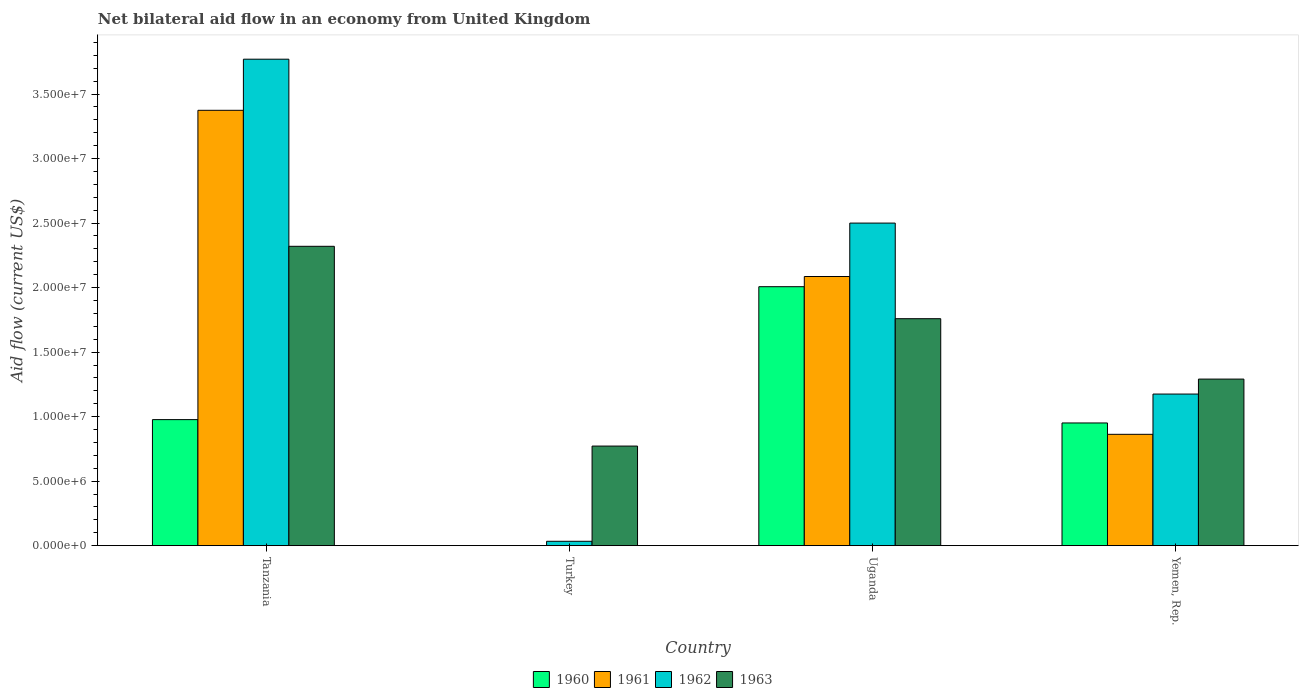How many different coloured bars are there?
Offer a terse response. 4. How many groups of bars are there?
Your answer should be very brief. 4. What is the label of the 3rd group of bars from the left?
Your answer should be compact. Uganda. Across all countries, what is the maximum net bilateral aid flow in 1963?
Offer a very short reply. 2.32e+07. Across all countries, what is the minimum net bilateral aid flow in 1961?
Give a very brief answer. 0. In which country was the net bilateral aid flow in 1961 maximum?
Make the answer very short. Tanzania. What is the total net bilateral aid flow in 1960 in the graph?
Your response must be concise. 3.94e+07. What is the difference between the net bilateral aid flow in 1960 in Tanzania and that in Yemen, Rep.?
Offer a terse response. 2.60e+05. What is the difference between the net bilateral aid flow in 1962 in Tanzania and the net bilateral aid flow in 1960 in Yemen, Rep.?
Your answer should be very brief. 2.82e+07. What is the average net bilateral aid flow in 1962 per country?
Your response must be concise. 1.87e+07. What is the difference between the net bilateral aid flow of/in 1961 and net bilateral aid flow of/in 1963 in Tanzania?
Provide a short and direct response. 1.05e+07. What is the ratio of the net bilateral aid flow in 1961 in Tanzania to that in Yemen, Rep.?
Your answer should be very brief. 3.91. Is the difference between the net bilateral aid flow in 1961 in Tanzania and Yemen, Rep. greater than the difference between the net bilateral aid flow in 1963 in Tanzania and Yemen, Rep.?
Your answer should be compact. Yes. What is the difference between the highest and the second highest net bilateral aid flow in 1962?
Your answer should be very brief. 1.27e+07. What is the difference between the highest and the lowest net bilateral aid flow in 1962?
Offer a very short reply. 3.74e+07. How many countries are there in the graph?
Offer a terse response. 4. What is the difference between two consecutive major ticks on the Y-axis?
Provide a succinct answer. 5.00e+06. Does the graph contain grids?
Your answer should be very brief. No. Where does the legend appear in the graph?
Offer a terse response. Bottom center. What is the title of the graph?
Provide a succinct answer. Net bilateral aid flow in an economy from United Kingdom. Does "2008" appear as one of the legend labels in the graph?
Your response must be concise. No. What is the Aid flow (current US$) in 1960 in Tanzania?
Your answer should be compact. 9.77e+06. What is the Aid flow (current US$) of 1961 in Tanzania?
Keep it short and to the point. 3.37e+07. What is the Aid flow (current US$) in 1962 in Tanzania?
Your answer should be compact. 3.77e+07. What is the Aid flow (current US$) of 1963 in Tanzania?
Keep it short and to the point. 2.32e+07. What is the Aid flow (current US$) in 1960 in Turkey?
Provide a succinct answer. 0. What is the Aid flow (current US$) of 1963 in Turkey?
Keep it short and to the point. 7.72e+06. What is the Aid flow (current US$) in 1960 in Uganda?
Offer a very short reply. 2.01e+07. What is the Aid flow (current US$) of 1961 in Uganda?
Offer a very short reply. 2.09e+07. What is the Aid flow (current US$) in 1962 in Uganda?
Offer a very short reply. 2.50e+07. What is the Aid flow (current US$) of 1963 in Uganda?
Offer a very short reply. 1.76e+07. What is the Aid flow (current US$) of 1960 in Yemen, Rep.?
Your response must be concise. 9.51e+06. What is the Aid flow (current US$) of 1961 in Yemen, Rep.?
Your response must be concise. 8.63e+06. What is the Aid flow (current US$) in 1962 in Yemen, Rep.?
Offer a terse response. 1.18e+07. What is the Aid flow (current US$) in 1963 in Yemen, Rep.?
Offer a very short reply. 1.29e+07. Across all countries, what is the maximum Aid flow (current US$) of 1960?
Provide a succinct answer. 2.01e+07. Across all countries, what is the maximum Aid flow (current US$) of 1961?
Your response must be concise. 3.37e+07. Across all countries, what is the maximum Aid flow (current US$) in 1962?
Offer a terse response. 3.77e+07. Across all countries, what is the maximum Aid flow (current US$) in 1963?
Keep it short and to the point. 2.32e+07. Across all countries, what is the minimum Aid flow (current US$) in 1963?
Ensure brevity in your answer.  7.72e+06. What is the total Aid flow (current US$) in 1960 in the graph?
Keep it short and to the point. 3.94e+07. What is the total Aid flow (current US$) in 1961 in the graph?
Provide a succinct answer. 6.32e+07. What is the total Aid flow (current US$) in 1962 in the graph?
Make the answer very short. 7.48e+07. What is the total Aid flow (current US$) of 1963 in the graph?
Offer a very short reply. 6.14e+07. What is the difference between the Aid flow (current US$) in 1962 in Tanzania and that in Turkey?
Offer a terse response. 3.74e+07. What is the difference between the Aid flow (current US$) in 1963 in Tanzania and that in Turkey?
Ensure brevity in your answer.  1.55e+07. What is the difference between the Aid flow (current US$) of 1960 in Tanzania and that in Uganda?
Make the answer very short. -1.03e+07. What is the difference between the Aid flow (current US$) of 1961 in Tanzania and that in Uganda?
Your answer should be very brief. 1.29e+07. What is the difference between the Aid flow (current US$) in 1962 in Tanzania and that in Uganda?
Provide a succinct answer. 1.27e+07. What is the difference between the Aid flow (current US$) of 1963 in Tanzania and that in Uganda?
Provide a short and direct response. 5.61e+06. What is the difference between the Aid flow (current US$) in 1960 in Tanzania and that in Yemen, Rep.?
Keep it short and to the point. 2.60e+05. What is the difference between the Aid flow (current US$) in 1961 in Tanzania and that in Yemen, Rep.?
Provide a short and direct response. 2.51e+07. What is the difference between the Aid flow (current US$) of 1962 in Tanzania and that in Yemen, Rep.?
Your answer should be compact. 2.60e+07. What is the difference between the Aid flow (current US$) of 1963 in Tanzania and that in Yemen, Rep.?
Ensure brevity in your answer.  1.03e+07. What is the difference between the Aid flow (current US$) of 1962 in Turkey and that in Uganda?
Offer a terse response. -2.47e+07. What is the difference between the Aid flow (current US$) in 1963 in Turkey and that in Uganda?
Provide a succinct answer. -9.87e+06. What is the difference between the Aid flow (current US$) in 1962 in Turkey and that in Yemen, Rep.?
Offer a very short reply. -1.14e+07. What is the difference between the Aid flow (current US$) in 1963 in Turkey and that in Yemen, Rep.?
Offer a very short reply. -5.19e+06. What is the difference between the Aid flow (current US$) of 1960 in Uganda and that in Yemen, Rep.?
Your answer should be very brief. 1.06e+07. What is the difference between the Aid flow (current US$) of 1961 in Uganda and that in Yemen, Rep.?
Give a very brief answer. 1.22e+07. What is the difference between the Aid flow (current US$) in 1962 in Uganda and that in Yemen, Rep.?
Give a very brief answer. 1.32e+07. What is the difference between the Aid flow (current US$) of 1963 in Uganda and that in Yemen, Rep.?
Your answer should be very brief. 4.68e+06. What is the difference between the Aid flow (current US$) in 1960 in Tanzania and the Aid flow (current US$) in 1962 in Turkey?
Provide a succinct answer. 9.43e+06. What is the difference between the Aid flow (current US$) in 1960 in Tanzania and the Aid flow (current US$) in 1963 in Turkey?
Give a very brief answer. 2.05e+06. What is the difference between the Aid flow (current US$) in 1961 in Tanzania and the Aid flow (current US$) in 1962 in Turkey?
Keep it short and to the point. 3.34e+07. What is the difference between the Aid flow (current US$) in 1961 in Tanzania and the Aid flow (current US$) in 1963 in Turkey?
Offer a terse response. 2.60e+07. What is the difference between the Aid flow (current US$) of 1962 in Tanzania and the Aid flow (current US$) of 1963 in Turkey?
Provide a succinct answer. 3.00e+07. What is the difference between the Aid flow (current US$) of 1960 in Tanzania and the Aid flow (current US$) of 1961 in Uganda?
Ensure brevity in your answer.  -1.11e+07. What is the difference between the Aid flow (current US$) in 1960 in Tanzania and the Aid flow (current US$) in 1962 in Uganda?
Give a very brief answer. -1.52e+07. What is the difference between the Aid flow (current US$) of 1960 in Tanzania and the Aid flow (current US$) of 1963 in Uganda?
Ensure brevity in your answer.  -7.82e+06. What is the difference between the Aid flow (current US$) in 1961 in Tanzania and the Aid flow (current US$) in 1962 in Uganda?
Keep it short and to the point. 8.74e+06. What is the difference between the Aid flow (current US$) of 1961 in Tanzania and the Aid flow (current US$) of 1963 in Uganda?
Provide a succinct answer. 1.62e+07. What is the difference between the Aid flow (current US$) in 1962 in Tanzania and the Aid flow (current US$) in 1963 in Uganda?
Keep it short and to the point. 2.01e+07. What is the difference between the Aid flow (current US$) in 1960 in Tanzania and the Aid flow (current US$) in 1961 in Yemen, Rep.?
Your answer should be compact. 1.14e+06. What is the difference between the Aid flow (current US$) of 1960 in Tanzania and the Aid flow (current US$) of 1962 in Yemen, Rep.?
Your answer should be very brief. -1.98e+06. What is the difference between the Aid flow (current US$) of 1960 in Tanzania and the Aid flow (current US$) of 1963 in Yemen, Rep.?
Your answer should be compact. -3.14e+06. What is the difference between the Aid flow (current US$) of 1961 in Tanzania and the Aid flow (current US$) of 1962 in Yemen, Rep.?
Provide a succinct answer. 2.20e+07. What is the difference between the Aid flow (current US$) in 1961 in Tanzania and the Aid flow (current US$) in 1963 in Yemen, Rep.?
Ensure brevity in your answer.  2.08e+07. What is the difference between the Aid flow (current US$) in 1962 in Tanzania and the Aid flow (current US$) in 1963 in Yemen, Rep.?
Provide a short and direct response. 2.48e+07. What is the difference between the Aid flow (current US$) of 1962 in Turkey and the Aid flow (current US$) of 1963 in Uganda?
Your answer should be very brief. -1.72e+07. What is the difference between the Aid flow (current US$) in 1962 in Turkey and the Aid flow (current US$) in 1963 in Yemen, Rep.?
Your answer should be very brief. -1.26e+07. What is the difference between the Aid flow (current US$) in 1960 in Uganda and the Aid flow (current US$) in 1961 in Yemen, Rep.?
Make the answer very short. 1.14e+07. What is the difference between the Aid flow (current US$) of 1960 in Uganda and the Aid flow (current US$) of 1962 in Yemen, Rep.?
Keep it short and to the point. 8.32e+06. What is the difference between the Aid flow (current US$) of 1960 in Uganda and the Aid flow (current US$) of 1963 in Yemen, Rep.?
Ensure brevity in your answer.  7.16e+06. What is the difference between the Aid flow (current US$) of 1961 in Uganda and the Aid flow (current US$) of 1962 in Yemen, Rep.?
Provide a short and direct response. 9.11e+06. What is the difference between the Aid flow (current US$) of 1961 in Uganda and the Aid flow (current US$) of 1963 in Yemen, Rep.?
Your answer should be compact. 7.95e+06. What is the difference between the Aid flow (current US$) in 1962 in Uganda and the Aid flow (current US$) in 1963 in Yemen, Rep.?
Ensure brevity in your answer.  1.21e+07. What is the average Aid flow (current US$) of 1960 per country?
Ensure brevity in your answer.  9.84e+06. What is the average Aid flow (current US$) in 1961 per country?
Provide a succinct answer. 1.58e+07. What is the average Aid flow (current US$) in 1962 per country?
Make the answer very short. 1.87e+07. What is the average Aid flow (current US$) in 1963 per country?
Make the answer very short. 1.54e+07. What is the difference between the Aid flow (current US$) in 1960 and Aid flow (current US$) in 1961 in Tanzania?
Your response must be concise. -2.40e+07. What is the difference between the Aid flow (current US$) in 1960 and Aid flow (current US$) in 1962 in Tanzania?
Make the answer very short. -2.79e+07. What is the difference between the Aid flow (current US$) in 1960 and Aid flow (current US$) in 1963 in Tanzania?
Your response must be concise. -1.34e+07. What is the difference between the Aid flow (current US$) of 1961 and Aid flow (current US$) of 1962 in Tanzania?
Offer a very short reply. -3.96e+06. What is the difference between the Aid flow (current US$) of 1961 and Aid flow (current US$) of 1963 in Tanzania?
Your answer should be very brief. 1.05e+07. What is the difference between the Aid flow (current US$) of 1962 and Aid flow (current US$) of 1963 in Tanzania?
Provide a short and direct response. 1.45e+07. What is the difference between the Aid flow (current US$) of 1962 and Aid flow (current US$) of 1963 in Turkey?
Your answer should be compact. -7.38e+06. What is the difference between the Aid flow (current US$) in 1960 and Aid flow (current US$) in 1961 in Uganda?
Offer a terse response. -7.90e+05. What is the difference between the Aid flow (current US$) in 1960 and Aid flow (current US$) in 1962 in Uganda?
Offer a terse response. -4.93e+06. What is the difference between the Aid flow (current US$) in 1960 and Aid flow (current US$) in 1963 in Uganda?
Ensure brevity in your answer.  2.48e+06. What is the difference between the Aid flow (current US$) in 1961 and Aid flow (current US$) in 1962 in Uganda?
Provide a succinct answer. -4.14e+06. What is the difference between the Aid flow (current US$) of 1961 and Aid flow (current US$) of 1963 in Uganda?
Provide a short and direct response. 3.27e+06. What is the difference between the Aid flow (current US$) of 1962 and Aid flow (current US$) of 1963 in Uganda?
Make the answer very short. 7.41e+06. What is the difference between the Aid flow (current US$) in 1960 and Aid flow (current US$) in 1961 in Yemen, Rep.?
Your response must be concise. 8.80e+05. What is the difference between the Aid flow (current US$) in 1960 and Aid flow (current US$) in 1962 in Yemen, Rep.?
Your response must be concise. -2.24e+06. What is the difference between the Aid flow (current US$) in 1960 and Aid flow (current US$) in 1963 in Yemen, Rep.?
Provide a short and direct response. -3.40e+06. What is the difference between the Aid flow (current US$) of 1961 and Aid flow (current US$) of 1962 in Yemen, Rep.?
Ensure brevity in your answer.  -3.12e+06. What is the difference between the Aid flow (current US$) in 1961 and Aid flow (current US$) in 1963 in Yemen, Rep.?
Offer a terse response. -4.28e+06. What is the difference between the Aid flow (current US$) of 1962 and Aid flow (current US$) of 1963 in Yemen, Rep.?
Keep it short and to the point. -1.16e+06. What is the ratio of the Aid flow (current US$) in 1962 in Tanzania to that in Turkey?
Your answer should be very brief. 110.88. What is the ratio of the Aid flow (current US$) of 1963 in Tanzania to that in Turkey?
Your answer should be very brief. 3.01. What is the ratio of the Aid flow (current US$) in 1960 in Tanzania to that in Uganda?
Your answer should be very brief. 0.49. What is the ratio of the Aid flow (current US$) in 1961 in Tanzania to that in Uganda?
Make the answer very short. 1.62. What is the ratio of the Aid flow (current US$) of 1962 in Tanzania to that in Uganda?
Offer a terse response. 1.51. What is the ratio of the Aid flow (current US$) of 1963 in Tanzania to that in Uganda?
Offer a very short reply. 1.32. What is the ratio of the Aid flow (current US$) of 1960 in Tanzania to that in Yemen, Rep.?
Provide a short and direct response. 1.03. What is the ratio of the Aid flow (current US$) in 1961 in Tanzania to that in Yemen, Rep.?
Offer a terse response. 3.91. What is the ratio of the Aid flow (current US$) in 1962 in Tanzania to that in Yemen, Rep.?
Offer a terse response. 3.21. What is the ratio of the Aid flow (current US$) of 1963 in Tanzania to that in Yemen, Rep.?
Your answer should be compact. 1.8. What is the ratio of the Aid flow (current US$) in 1962 in Turkey to that in Uganda?
Offer a very short reply. 0.01. What is the ratio of the Aid flow (current US$) in 1963 in Turkey to that in Uganda?
Provide a succinct answer. 0.44. What is the ratio of the Aid flow (current US$) in 1962 in Turkey to that in Yemen, Rep.?
Offer a very short reply. 0.03. What is the ratio of the Aid flow (current US$) of 1963 in Turkey to that in Yemen, Rep.?
Provide a short and direct response. 0.6. What is the ratio of the Aid flow (current US$) in 1960 in Uganda to that in Yemen, Rep.?
Ensure brevity in your answer.  2.11. What is the ratio of the Aid flow (current US$) of 1961 in Uganda to that in Yemen, Rep.?
Your response must be concise. 2.42. What is the ratio of the Aid flow (current US$) of 1962 in Uganda to that in Yemen, Rep.?
Provide a succinct answer. 2.13. What is the ratio of the Aid flow (current US$) in 1963 in Uganda to that in Yemen, Rep.?
Your answer should be very brief. 1.36. What is the difference between the highest and the second highest Aid flow (current US$) of 1960?
Provide a succinct answer. 1.03e+07. What is the difference between the highest and the second highest Aid flow (current US$) of 1961?
Your response must be concise. 1.29e+07. What is the difference between the highest and the second highest Aid flow (current US$) of 1962?
Your answer should be compact. 1.27e+07. What is the difference between the highest and the second highest Aid flow (current US$) of 1963?
Keep it short and to the point. 5.61e+06. What is the difference between the highest and the lowest Aid flow (current US$) in 1960?
Make the answer very short. 2.01e+07. What is the difference between the highest and the lowest Aid flow (current US$) in 1961?
Give a very brief answer. 3.37e+07. What is the difference between the highest and the lowest Aid flow (current US$) in 1962?
Offer a terse response. 3.74e+07. What is the difference between the highest and the lowest Aid flow (current US$) in 1963?
Give a very brief answer. 1.55e+07. 